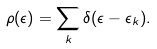Convert formula to latex. <formula><loc_0><loc_0><loc_500><loc_500>\rho ( \epsilon ) = \sum _ { k } \delta ( \epsilon - \epsilon _ { k } ) .</formula> 